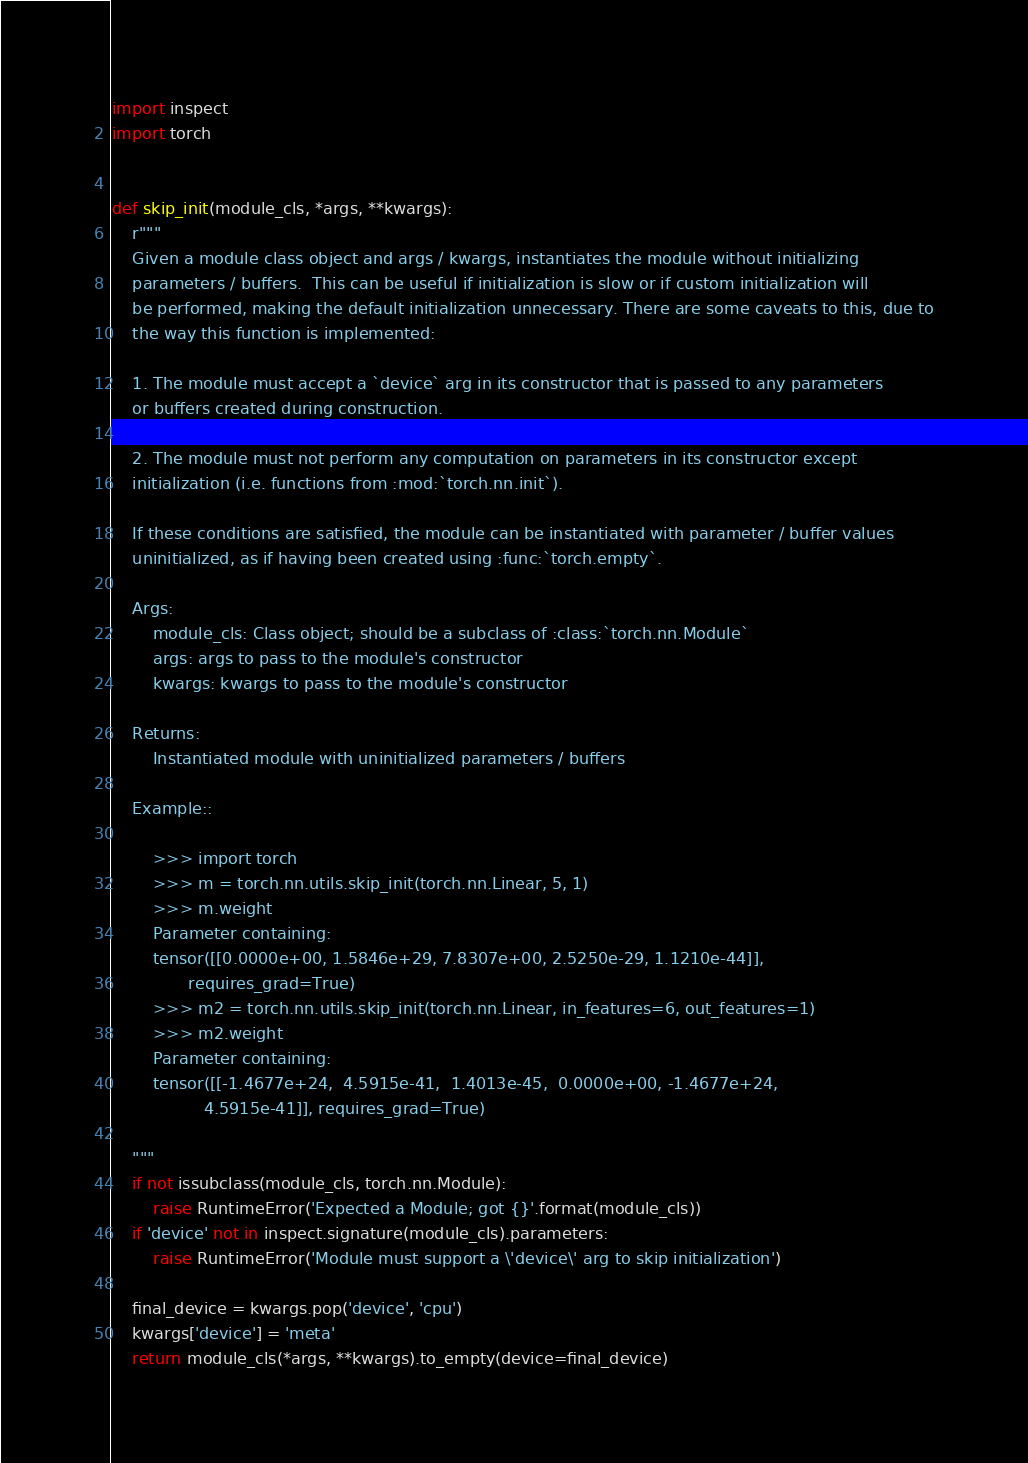<code> <loc_0><loc_0><loc_500><loc_500><_Python_>import inspect
import torch


def skip_init(module_cls, *args, **kwargs):
    r"""
    Given a module class object and args / kwargs, instantiates the module without initializing
    parameters / buffers.  This can be useful if initialization is slow or if custom initialization will
    be performed, making the default initialization unnecessary. There are some caveats to this, due to
    the way this function is implemented:

    1. The module must accept a `device` arg in its constructor that is passed to any parameters
    or buffers created during construction.

    2. The module must not perform any computation on parameters in its constructor except
    initialization (i.e. functions from :mod:`torch.nn.init`).

    If these conditions are satisfied, the module can be instantiated with parameter / buffer values
    uninitialized, as if having been created using :func:`torch.empty`.

    Args:
        module_cls: Class object; should be a subclass of :class:`torch.nn.Module`
        args: args to pass to the module's constructor
        kwargs: kwargs to pass to the module's constructor

    Returns:
        Instantiated module with uninitialized parameters / buffers

    Example::

        >>> import torch
        >>> m = torch.nn.utils.skip_init(torch.nn.Linear, 5, 1)
        >>> m.weight
        Parameter containing:
        tensor([[0.0000e+00, 1.5846e+29, 7.8307e+00, 2.5250e-29, 1.1210e-44]],
               requires_grad=True)
        >>> m2 = torch.nn.utils.skip_init(torch.nn.Linear, in_features=6, out_features=1)
        >>> m2.weight
        Parameter containing:
        tensor([[-1.4677e+24,  4.5915e-41,  1.4013e-45,  0.0000e+00, -1.4677e+24,
                  4.5915e-41]], requires_grad=True)

    """
    if not issubclass(module_cls, torch.nn.Module):
        raise RuntimeError('Expected a Module; got {}'.format(module_cls))
    if 'device' not in inspect.signature(module_cls).parameters:
        raise RuntimeError('Module must support a \'device\' arg to skip initialization')

    final_device = kwargs.pop('device', 'cpu')
    kwargs['device'] = 'meta'
    return module_cls(*args, **kwargs).to_empty(device=final_device)
</code> 